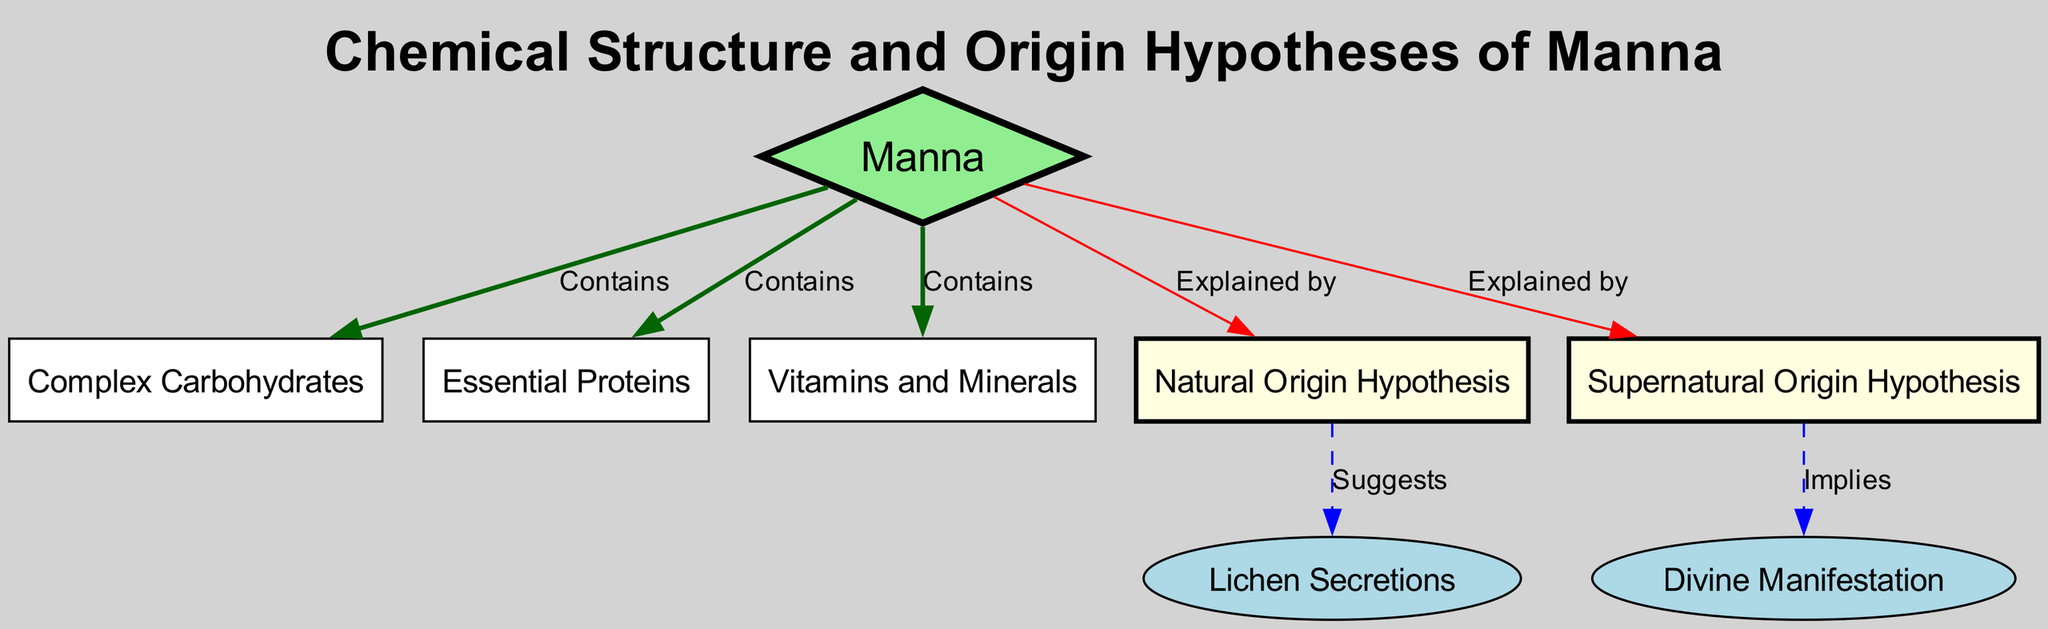What's the primary component that manna contains? The diagram shows that manna contains multiple components, including complex carbohydrates, essential proteins, and vitamins and minerals. The question specifically asks for the primary component. Based on the diagram structure, the term "Contains" leads directly to the three components listed.
Answer: Complex Carbohydrates How many hypotheses are presented regarding the origin of manna? In the diagram, there are two hypotheses indicated under the main node "Manna" which are labeled as "Natural Origin Hypothesis" and "Supernatural Origin Hypothesis". To answer the question, I counted the distinct hypotheses illustrated on the diagram.
Answer: 2 What does the Natural Origin Hypothesis suggest? The Natural Origin Hypothesis is linked to the "Lichen Secretions" node. According to the diagram, it provides a suggestion or explanation related to the natural occurrence of manna. Therefore, the answer is derived from following the edge labeled "Suggests".
Answer: Lichen Secretions What does the Supernatural Origin Hypothesis imply? The diagram indicates that the Supernatural Origin Hypothesis is associated with the "Divine Manifestation" node. The connection is made through the edge labeled "Implies". Thus, to answer the question, I traced the line from the Supernatural Origin node to the Divine Manifestation node.
Answer: Divine Manifestation How many nodes are directly linked to manna? Upon examining the diagram, I noted that manna is directly linked to three nodes: Complex Carbohydrates, Essential Proteins, and Vitamins and Minerals. Each of these nodes is indicated with an edge labeled "Contains". Counting these direct connections allows me to answer the question.
Answer: 3 What color is the node representing Manna? The diagram specifies that the node representing Manna is colored light green. This is stated in the section outlining the styles for each node in the created diagram. The answer comes directly from observing the node color in the rendered diagram.
Answer: Light Green What is the relationship between Manna and the Natural Origin Hypothesis? The relationship is explained by an edge that is drawn between the Manna and Natural Origin nodes, labeled "Explained by". This indicates that one node provides an explanation or rationale for the other. Thus, following the edge gives clarity to this relationship.
Answer: Explained by What type of diagram is this? This diagram is categorized as a Graduate Level Diagram since it presents complex interrelations among various scientific components while addressing hypotheses surrounding manna's chemical structure and origins. This definition is aligned with the characteristics provided in the context of the task.
Answer: Graduate Level Diagram 